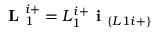Convert formula to latex. <formula><loc_0><loc_0><loc_500><loc_500>L _ { 1 } ^ { i + } = L _ { 1 } ^ { i + } i _ { \{ L 1 i + \} }</formula> 